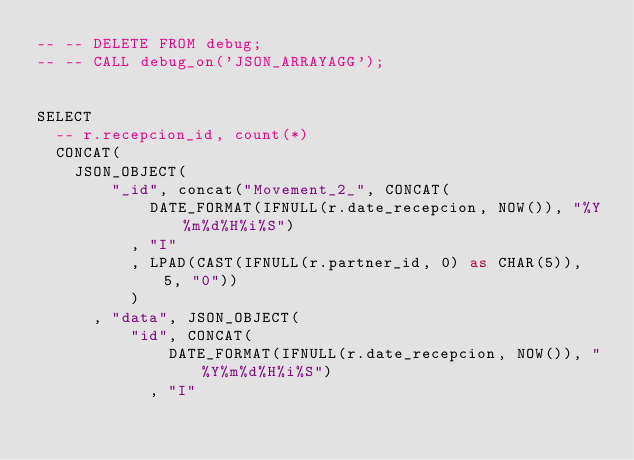Convert code to text. <code><loc_0><loc_0><loc_500><loc_500><_SQL_>-- -- DELETE FROM debug;
-- -- CALL debug_on('JSON_ARRAYAGG');


SELECT
  -- r.recepcion_id, count(*)
  CONCAT(
    JSON_OBJECT(
        "_id", concat("Movement_2_", CONCAT(
            DATE_FORMAT(IFNULL(r.date_recepcion, NOW()), "%Y%m%d%H%i%S")
          , "I"
          , LPAD(CAST(IFNULL(r.partner_id, 0) as CHAR(5)), 5, "0"))
          )
      , "data", JSON_OBJECT(
          "id", CONCAT(
              DATE_FORMAT(IFNULL(r.date_recepcion, NOW()), "%Y%m%d%H%i%S")
            , "I"</code> 